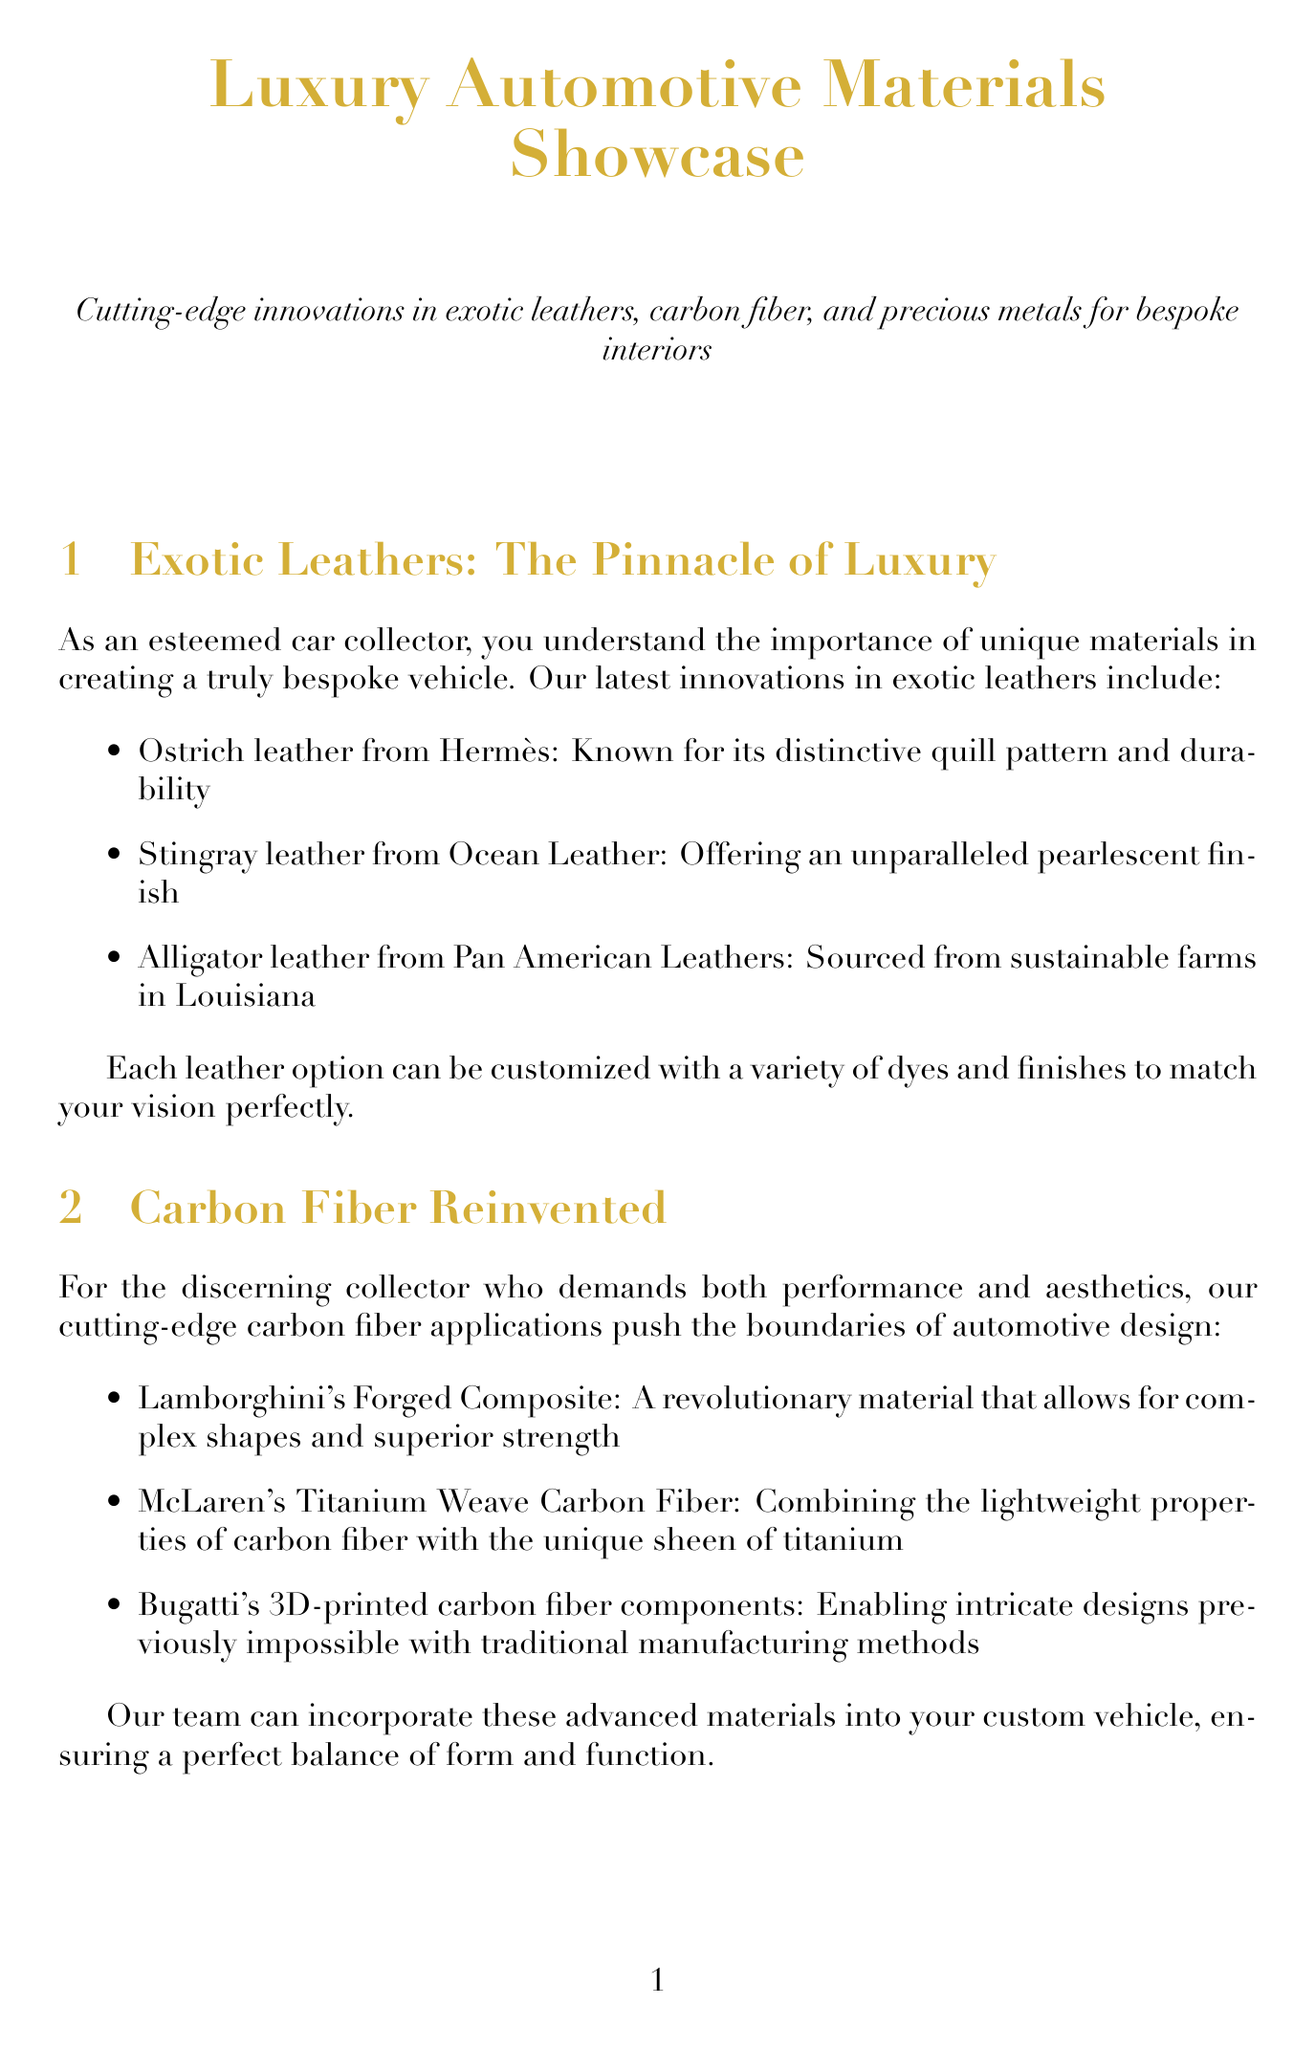What types of exotic leathers are mentioned? The document lists exotic leathers including ostrich, stingray, and alligator leather.
Answer: Ostrich, stingray, alligator Who leads the team of master craftsmen? The document states that renowned automotive designer Henrik Fisker leads the team.
Answer: Henrik Fisker What is an innovation in carbon fiber mentioned in the newsletter? Among the innovations, Lamborghini's Forged Composite is highlighted in the document.
Answer: Lamborghini's Forged Composite How many precious metal accents are listed? The document provides three precious metal accents available for interior design.
Answer: Three What sustainable material is associated with Tesla? The document describes a vegan leather alternative associated with Tesla.
Answer: Vegan leather alternative What type of stitching patterns can be customized? The document specifies custom stitching patterns offered using Rolls-Royce's machines.
Answer: Custom stitching patterns Which leather is sourced from sustainable farms in Louisiana? The document identifies the alligator leather as being sourced from sustainable farms.
Answer: Alligator leather What is the primary focus of the newsletter? The newsletter focuses on cutting-edge innovations in luxury automotive materials.
Answer: Cutting-edge innovations in luxury automotive materials 